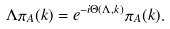<formula> <loc_0><loc_0><loc_500><loc_500>\Lambda \pi _ { A } ( { k } ) = e ^ { - i \Theta ( \Lambda , { k } ) } \pi _ { A } ( { k } ) .</formula> 